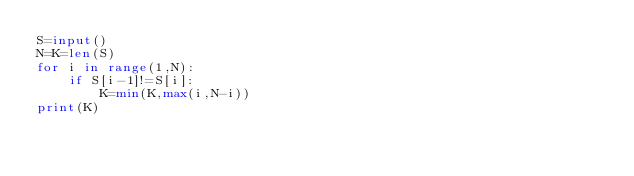<code> <loc_0><loc_0><loc_500><loc_500><_Python_>S=input()
N=K=len(S)
for i in range(1,N):
    if S[i-1]!=S[i]:
        K=min(K,max(i,N-i))
print(K)</code> 